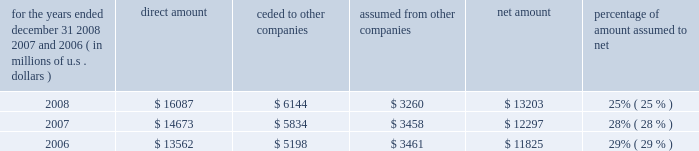S c h e d u l e i v ( continued ) ace limited and subsidiaries s u p p l e m e n t a l i n f o r m a t i o n c o n c e r n i n g r e i n s u r a n c e premiums earned for the years ended december 31 , 2008 , 2007 , and 2006 ( in millions of u.s .
Dollars ) direct amount ceded to companies assumed from other companies net amount percentage of amount assumed to .

What is the growth rate of net amount from 2007 to 2008? 
Computations: ((13203 - 12297) / 12297)
Answer: 0.07368. S c h e d u l e i v ( continued ) ace limited and subsidiaries s u p p l e m e n t a l i n f o r m a t i o n c o n c e r n i n g r e i n s u r a n c e premiums earned for the years ended december 31 , 2008 , 2007 , and 2006 ( in millions of u.s .
Dollars ) direct amount ceded to companies assumed from other companies net amount percentage of amount assumed to .

What is the percentage of amount ceded to direct amount in 2007? 
Computations: (5834 / 14673)
Answer: 0.3976. 